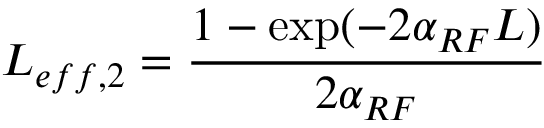<formula> <loc_0><loc_0><loc_500><loc_500>L _ { e f f , 2 } = \frac { 1 - \exp ( - 2 \alpha _ { R F } L ) } { 2 \alpha _ { R F } }</formula> 